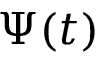Convert formula to latex. <formula><loc_0><loc_0><loc_500><loc_500>\Psi ( t )</formula> 